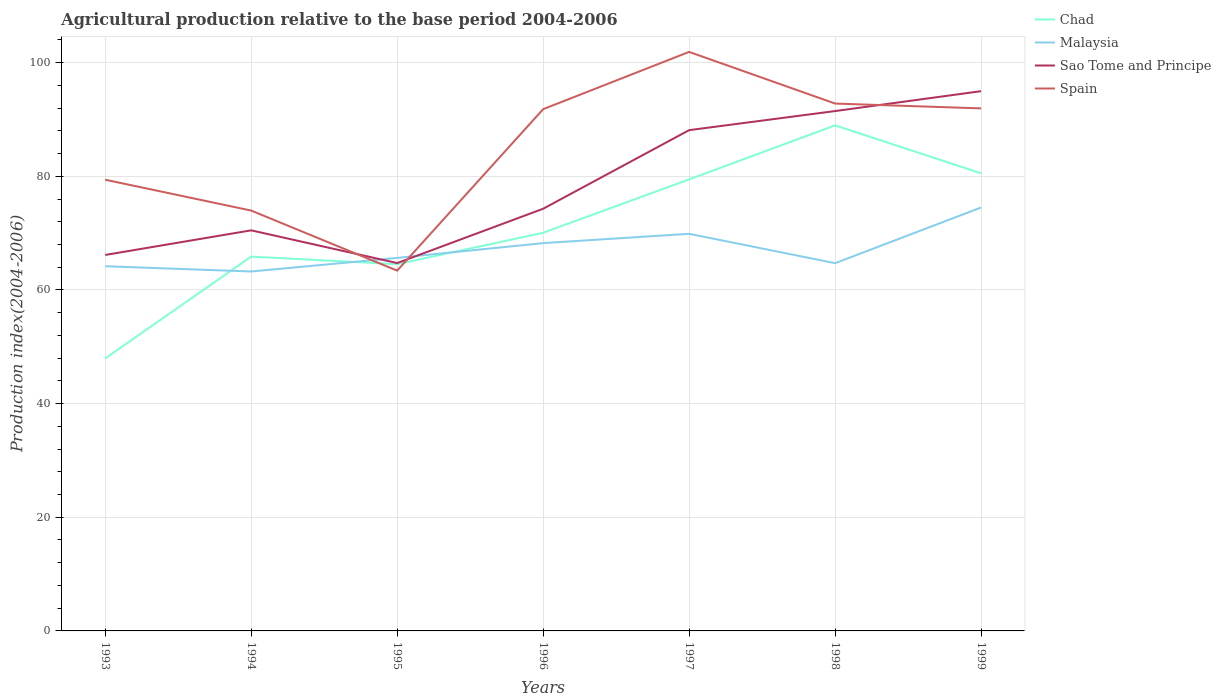Does the line corresponding to Spain intersect with the line corresponding to Malaysia?
Make the answer very short. Yes. Across all years, what is the maximum agricultural production index in Malaysia?
Keep it short and to the point. 63.25. What is the total agricultural production index in Chad in the graph?
Make the answer very short. -17.92. What is the difference between the highest and the second highest agricultural production index in Sao Tome and Principe?
Offer a very short reply. 30.25. How many lines are there?
Provide a short and direct response. 4. Where does the legend appear in the graph?
Your answer should be compact. Top right. How are the legend labels stacked?
Give a very brief answer. Vertical. What is the title of the graph?
Make the answer very short. Agricultural production relative to the base period 2004-2006. Does "Mali" appear as one of the legend labels in the graph?
Offer a very short reply. No. What is the label or title of the X-axis?
Make the answer very short. Years. What is the label or title of the Y-axis?
Provide a succinct answer. Production index(2004-2006). What is the Production index(2004-2006) in Chad in 1993?
Provide a succinct answer. 47.95. What is the Production index(2004-2006) of Malaysia in 1993?
Provide a short and direct response. 64.17. What is the Production index(2004-2006) in Sao Tome and Principe in 1993?
Give a very brief answer. 66.16. What is the Production index(2004-2006) in Spain in 1993?
Your answer should be very brief. 79.4. What is the Production index(2004-2006) of Chad in 1994?
Your response must be concise. 65.87. What is the Production index(2004-2006) in Malaysia in 1994?
Provide a succinct answer. 63.25. What is the Production index(2004-2006) in Sao Tome and Principe in 1994?
Your response must be concise. 70.49. What is the Production index(2004-2006) in Spain in 1994?
Provide a succinct answer. 73.97. What is the Production index(2004-2006) of Chad in 1995?
Provide a short and direct response. 64.53. What is the Production index(2004-2006) in Malaysia in 1995?
Make the answer very short. 65.64. What is the Production index(2004-2006) of Sao Tome and Principe in 1995?
Your answer should be very brief. 64.73. What is the Production index(2004-2006) in Spain in 1995?
Give a very brief answer. 63.4. What is the Production index(2004-2006) in Chad in 1996?
Make the answer very short. 70.06. What is the Production index(2004-2006) in Malaysia in 1996?
Provide a short and direct response. 68.24. What is the Production index(2004-2006) in Sao Tome and Principe in 1996?
Your response must be concise. 74.29. What is the Production index(2004-2006) in Spain in 1996?
Your response must be concise. 91.81. What is the Production index(2004-2006) in Chad in 1997?
Provide a succinct answer. 79.46. What is the Production index(2004-2006) in Malaysia in 1997?
Provide a short and direct response. 69.88. What is the Production index(2004-2006) in Sao Tome and Principe in 1997?
Make the answer very short. 88.12. What is the Production index(2004-2006) in Spain in 1997?
Keep it short and to the point. 101.89. What is the Production index(2004-2006) of Chad in 1998?
Your answer should be compact. 88.96. What is the Production index(2004-2006) in Malaysia in 1998?
Keep it short and to the point. 64.71. What is the Production index(2004-2006) of Sao Tome and Principe in 1998?
Your answer should be compact. 91.48. What is the Production index(2004-2006) of Spain in 1998?
Offer a very short reply. 92.8. What is the Production index(2004-2006) of Chad in 1999?
Ensure brevity in your answer.  80.53. What is the Production index(2004-2006) in Malaysia in 1999?
Give a very brief answer. 74.51. What is the Production index(2004-2006) of Sao Tome and Principe in 1999?
Make the answer very short. 94.98. What is the Production index(2004-2006) of Spain in 1999?
Your answer should be very brief. 91.95. Across all years, what is the maximum Production index(2004-2006) in Chad?
Ensure brevity in your answer.  88.96. Across all years, what is the maximum Production index(2004-2006) of Malaysia?
Your answer should be compact. 74.51. Across all years, what is the maximum Production index(2004-2006) in Sao Tome and Principe?
Make the answer very short. 94.98. Across all years, what is the maximum Production index(2004-2006) in Spain?
Your answer should be compact. 101.89. Across all years, what is the minimum Production index(2004-2006) of Chad?
Provide a short and direct response. 47.95. Across all years, what is the minimum Production index(2004-2006) of Malaysia?
Your response must be concise. 63.25. Across all years, what is the minimum Production index(2004-2006) in Sao Tome and Principe?
Offer a terse response. 64.73. Across all years, what is the minimum Production index(2004-2006) of Spain?
Your response must be concise. 63.4. What is the total Production index(2004-2006) of Chad in the graph?
Provide a succinct answer. 497.36. What is the total Production index(2004-2006) of Malaysia in the graph?
Keep it short and to the point. 470.4. What is the total Production index(2004-2006) in Sao Tome and Principe in the graph?
Keep it short and to the point. 550.25. What is the total Production index(2004-2006) of Spain in the graph?
Keep it short and to the point. 595.22. What is the difference between the Production index(2004-2006) in Chad in 1993 and that in 1994?
Provide a short and direct response. -17.92. What is the difference between the Production index(2004-2006) in Malaysia in 1993 and that in 1994?
Keep it short and to the point. 0.92. What is the difference between the Production index(2004-2006) of Sao Tome and Principe in 1993 and that in 1994?
Your response must be concise. -4.33. What is the difference between the Production index(2004-2006) in Spain in 1993 and that in 1994?
Ensure brevity in your answer.  5.43. What is the difference between the Production index(2004-2006) of Chad in 1993 and that in 1995?
Keep it short and to the point. -16.58. What is the difference between the Production index(2004-2006) of Malaysia in 1993 and that in 1995?
Keep it short and to the point. -1.47. What is the difference between the Production index(2004-2006) of Sao Tome and Principe in 1993 and that in 1995?
Your answer should be very brief. 1.43. What is the difference between the Production index(2004-2006) in Spain in 1993 and that in 1995?
Make the answer very short. 16. What is the difference between the Production index(2004-2006) in Chad in 1993 and that in 1996?
Offer a terse response. -22.11. What is the difference between the Production index(2004-2006) in Malaysia in 1993 and that in 1996?
Your answer should be compact. -4.07. What is the difference between the Production index(2004-2006) of Sao Tome and Principe in 1993 and that in 1996?
Keep it short and to the point. -8.13. What is the difference between the Production index(2004-2006) of Spain in 1993 and that in 1996?
Ensure brevity in your answer.  -12.41. What is the difference between the Production index(2004-2006) in Chad in 1993 and that in 1997?
Your answer should be very brief. -31.51. What is the difference between the Production index(2004-2006) in Malaysia in 1993 and that in 1997?
Your response must be concise. -5.71. What is the difference between the Production index(2004-2006) of Sao Tome and Principe in 1993 and that in 1997?
Ensure brevity in your answer.  -21.96. What is the difference between the Production index(2004-2006) of Spain in 1993 and that in 1997?
Provide a succinct answer. -22.49. What is the difference between the Production index(2004-2006) in Chad in 1993 and that in 1998?
Offer a very short reply. -41.01. What is the difference between the Production index(2004-2006) in Malaysia in 1993 and that in 1998?
Offer a terse response. -0.54. What is the difference between the Production index(2004-2006) of Sao Tome and Principe in 1993 and that in 1998?
Your answer should be very brief. -25.32. What is the difference between the Production index(2004-2006) of Spain in 1993 and that in 1998?
Provide a succinct answer. -13.4. What is the difference between the Production index(2004-2006) in Chad in 1993 and that in 1999?
Provide a succinct answer. -32.58. What is the difference between the Production index(2004-2006) of Malaysia in 1993 and that in 1999?
Your response must be concise. -10.34. What is the difference between the Production index(2004-2006) of Sao Tome and Principe in 1993 and that in 1999?
Provide a short and direct response. -28.82. What is the difference between the Production index(2004-2006) in Spain in 1993 and that in 1999?
Provide a short and direct response. -12.55. What is the difference between the Production index(2004-2006) of Chad in 1994 and that in 1995?
Keep it short and to the point. 1.34. What is the difference between the Production index(2004-2006) in Malaysia in 1994 and that in 1995?
Offer a very short reply. -2.39. What is the difference between the Production index(2004-2006) in Sao Tome and Principe in 1994 and that in 1995?
Provide a short and direct response. 5.76. What is the difference between the Production index(2004-2006) in Spain in 1994 and that in 1995?
Ensure brevity in your answer.  10.57. What is the difference between the Production index(2004-2006) of Chad in 1994 and that in 1996?
Give a very brief answer. -4.19. What is the difference between the Production index(2004-2006) in Malaysia in 1994 and that in 1996?
Provide a short and direct response. -4.99. What is the difference between the Production index(2004-2006) of Spain in 1994 and that in 1996?
Give a very brief answer. -17.84. What is the difference between the Production index(2004-2006) of Chad in 1994 and that in 1997?
Offer a very short reply. -13.59. What is the difference between the Production index(2004-2006) of Malaysia in 1994 and that in 1997?
Your answer should be compact. -6.63. What is the difference between the Production index(2004-2006) in Sao Tome and Principe in 1994 and that in 1997?
Your answer should be compact. -17.63. What is the difference between the Production index(2004-2006) in Spain in 1994 and that in 1997?
Provide a short and direct response. -27.92. What is the difference between the Production index(2004-2006) of Chad in 1994 and that in 1998?
Your response must be concise. -23.09. What is the difference between the Production index(2004-2006) in Malaysia in 1994 and that in 1998?
Make the answer very short. -1.46. What is the difference between the Production index(2004-2006) of Sao Tome and Principe in 1994 and that in 1998?
Give a very brief answer. -20.99. What is the difference between the Production index(2004-2006) of Spain in 1994 and that in 1998?
Your answer should be very brief. -18.83. What is the difference between the Production index(2004-2006) of Chad in 1994 and that in 1999?
Provide a short and direct response. -14.66. What is the difference between the Production index(2004-2006) of Malaysia in 1994 and that in 1999?
Your answer should be compact. -11.26. What is the difference between the Production index(2004-2006) in Sao Tome and Principe in 1994 and that in 1999?
Your response must be concise. -24.49. What is the difference between the Production index(2004-2006) of Spain in 1994 and that in 1999?
Ensure brevity in your answer.  -17.98. What is the difference between the Production index(2004-2006) in Chad in 1995 and that in 1996?
Offer a terse response. -5.53. What is the difference between the Production index(2004-2006) of Malaysia in 1995 and that in 1996?
Offer a terse response. -2.6. What is the difference between the Production index(2004-2006) of Sao Tome and Principe in 1995 and that in 1996?
Your answer should be very brief. -9.56. What is the difference between the Production index(2004-2006) in Spain in 1995 and that in 1996?
Provide a short and direct response. -28.41. What is the difference between the Production index(2004-2006) in Chad in 1995 and that in 1997?
Provide a succinct answer. -14.93. What is the difference between the Production index(2004-2006) of Malaysia in 1995 and that in 1997?
Your answer should be very brief. -4.24. What is the difference between the Production index(2004-2006) in Sao Tome and Principe in 1995 and that in 1997?
Your answer should be very brief. -23.39. What is the difference between the Production index(2004-2006) of Spain in 1995 and that in 1997?
Ensure brevity in your answer.  -38.49. What is the difference between the Production index(2004-2006) in Chad in 1995 and that in 1998?
Your answer should be very brief. -24.43. What is the difference between the Production index(2004-2006) in Sao Tome and Principe in 1995 and that in 1998?
Give a very brief answer. -26.75. What is the difference between the Production index(2004-2006) of Spain in 1995 and that in 1998?
Ensure brevity in your answer.  -29.4. What is the difference between the Production index(2004-2006) of Malaysia in 1995 and that in 1999?
Make the answer very short. -8.87. What is the difference between the Production index(2004-2006) in Sao Tome and Principe in 1995 and that in 1999?
Ensure brevity in your answer.  -30.25. What is the difference between the Production index(2004-2006) of Spain in 1995 and that in 1999?
Offer a very short reply. -28.55. What is the difference between the Production index(2004-2006) of Malaysia in 1996 and that in 1997?
Ensure brevity in your answer.  -1.64. What is the difference between the Production index(2004-2006) of Sao Tome and Principe in 1996 and that in 1997?
Your answer should be compact. -13.83. What is the difference between the Production index(2004-2006) in Spain in 1996 and that in 1997?
Offer a terse response. -10.08. What is the difference between the Production index(2004-2006) of Chad in 1996 and that in 1998?
Your answer should be very brief. -18.9. What is the difference between the Production index(2004-2006) of Malaysia in 1996 and that in 1998?
Offer a very short reply. 3.53. What is the difference between the Production index(2004-2006) in Sao Tome and Principe in 1996 and that in 1998?
Your answer should be compact. -17.19. What is the difference between the Production index(2004-2006) of Spain in 1996 and that in 1998?
Your answer should be compact. -0.99. What is the difference between the Production index(2004-2006) in Chad in 1996 and that in 1999?
Your answer should be compact. -10.47. What is the difference between the Production index(2004-2006) of Malaysia in 1996 and that in 1999?
Provide a succinct answer. -6.27. What is the difference between the Production index(2004-2006) of Sao Tome and Principe in 1996 and that in 1999?
Provide a succinct answer. -20.69. What is the difference between the Production index(2004-2006) in Spain in 1996 and that in 1999?
Ensure brevity in your answer.  -0.14. What is the difference between the Production index(2004-2006) of Chad in 1997 and that in 1998?
Offer a very short reply. -9.5. What is the difference between the Production index(2004-2006) in Malaysia in 1997 and that in 1998?
Ensure brevity in your answer.  5.17. What is the difference between the Production index(2004-2006) in Sao Tome and Principe in 1997 and that in 1998?
Offer a terse response. -3.36. What is the difference between the Production index(2004-2006) in Spain in 1997 and that in 1998?
Your answer should be compact. 9.09. What is the difference between the Production index(2004-2006) in Chad in 1997 and that in 1999?
Offer a terse response. -1.07. What is the difference between the Production index(2004-2006) of Malaysia in 1997 and that in 1999?
Provide a short and direct response. -4.63. What is the difference between the Production index(2004-2006) in Sao Tome and Principe in 1997 and that in 1999?
Provide a succinct answer. -6.86. What is the difference between the Production index(2004-2006) of Spain in 1997 and that in 1999?
Offer a terse response. 9.94. What is the difference between the Production index(2004-2006) of Chad in 1998 and that in 1999?
Provide a succinct answer. 8.43. What is the difference between the Production index(2004-2006) of Chad in 1993 and the Production index(2004-2006) of Malaysia in 1994?
Your response must be concise. -15.3. What is the difference between the Production index(2004-2006) of Chad in 1993 and the Production index(2004-2006) of Sao Tome and Principe in 1994?
Give a very brief answer. -22.54. What is the difference between the Production index(2004-2006) in Chad in 1993 and the Production index(2004-2006) in Spain in 1994?
Provide a succinct answer. -26.02. What is the difference between the Production index(2004-2006) in Malaysia in 1993 and the Production index(2004-2006) in Sao Tome and Principe in 1994?
Offer a terse response. -6.32. What is the difference between the Production index(2004-2006) of Sao Tome and Principe in 1993 and the Production index(2004-2006) of Spain in 1994?
Offer a very short reply. -7.81. What is the difference between the Production index(2004-2006) in Chad in 1993 and the Production index(2004-2006) in Malaysia in 1995?
Make the answer very short. -17.69. What is the difference between the Production index(2004-2006) of Chad in 1993 and the Production index(2004-2006) of Sao Tome and Principe in 1995?
Your response must be concise. -16.78. What is the difference between the Production index(2004-2006) of Chad in 1993 and the Production index(2004-2006) of Spain in 1995?
Make the answer very short. -15.45. What is the difference between the Production index(2004-2006) of Malaysia in 1993 and the Production index(2004-2006) of Sao Tome and Principe in 1995?
Keep it short and to the point. -0.56. What is the difference between the Production index(2004-2006) of Malaysia in 1993 and the Production index(2004-2006) of Spain in 1995?
Keep it short and to the point. 0.77. What is the difference between the Production index(2004-2006) in Sao Tome and Principe in 1993 and the Production index(2004-2006) in Spain in 1995?
Make the answer very short. 2.76. What is the difference between the Production index(2004-2006) in Chad in 1993 and the Production index(2004-2006) in Malaysia in 1996?
Provide a succinct answer. -20.29. What is the difference between the Production index(2004-2006) in Chad in 1993 and the Production index(2004-2006) in Sao Tome and Principe in 1996?
Offer a terse response. -26.34. What is the difference between the Production index(2004-2006) in Chad in 1993 and the Production index(2004-2006) in Spain in 1996?
Make the answer very short. -43.86. What is the difference between the Production index(2004-2006) of Malaysia in 1993 and the Production index(2004-2006) of Sao Tome and Principe in 1996?
Keep it short and to the point. -10.12. What is the difference between the Production index(2004-2006) of Malaysia in 1993 and the Production index(2004-2006) of Spain in 1996?
Ensure brevity in your answer.  -27.64. What is the difference between the Production index(2004-2006) of Sao Tome and Principe in 1993 and the Production index(2004-2006) of Spain in 1996?
Keep it short and to the point. -25.65. What is the difference between the Production index(2004-2006) in Chad in 1993 and the Production index(2004-2006) in Malaysia in 1997?
Make the answer very short. -21.93. What is the difference between the Production index(2004-2006) in Chad in 1993 and the Production index(2004-2006) in Sao Tome and Principe in 1997?
Offer a very short reply. -40.17. What is the difference between the Production index(2004-2006) in Chad in 1993 and the Production index(2004-2006) in Spain in 1997?
Give a very brief answer. -53.94. What is the difference between the Production index(2004-2006) of Malaysia in 1993 and the Production index(2004-2006) of Sao Tome and Principe in 1997?
Your answer should be compact. -23.95. What is the difference between the Production index(2004-2006) of Malaysia in 1993 and the Production index(2004-2006) of Spain in 1997?
Your response must be concise. -37.72. What is the difference between the Production index(2004-2006) of Sao Tome and Principe in 1993 and the Production index(2004-2006) of Spain in 1997?
Give a very brief answer. -35.73. What is the difference between the Production index(2004-2006) of Chad in 1993 and the Production index(2004-2006) of Malaysia in 1998?
Your answer should be compact. -16.76. What is the difference between the Production index(2004-2006) in Chad in 1993 and the Production index(2004-2006) in Sao Tome and Principe in 1998?
Ensure brevity in your answer.  -43.53. What is the difference between the Production index(2004-2006) in Chad in 1993 and the Production index(2004-2006) in Spain in 1998?
Keep it short and to the point. -44.85. What is the difference between the Production index(2004-2006) of Malaysia in 1993 and the Production index(2004-2006) of Sao Tome and Principe in 1998?
Your answer should be compact. -27.31. What is the difference between the Production index(2004-2006) in Malaysia in 1993 and the Production index(2004-2006) in Spain in 1998?
Offer a terse response. -28.63. What is the difference between the Production index(2004-2006) in Sao Tome and Principe in 1993 and the Production index(2004-2006) in Spain in 1998?
Offer a very short reply. -26.64. What is the difference between the Production index(2004-2006) of Chad in 1993 and the Production index(2004-2006) of Malaysia in 1999?
Your answer should be very brief. -26.56. What is the difference between the Production index(2004-2006) in Chad in 1993 and the Production index(2004-2006) in Sao Tome and Principe in 1999?
Make the answer very short. -47.03. What is the difference between the Production index(2004-2006) of Chad in 1993 and the Production index(2004-2006) of Spain in 1999?
Your answer should be very brief. -44. What is the difference between the Production index(2004-2006) in Malaysia in 1993 and the Production index(2004-2006) in Sao Tome and Principe in 1999?
Your answer should be very brief. -30.81. What is the difference between the Production index(2004-2006) in Malaysia in 1993 and the Production index(2004-2006) in Spain in 1999?
Keep it short and to the point. -27.78. What is the difference between the Production index(2004-2006) of Sao Tome and Principe in 1993 and the Production index(2004-2006) of Spain in 1999?
Provide a succinct answer. -25.79. What is the difference between the Production index(2004-2006) in Chad in 1994 and the Production index(2004-2006) in Malaysia in 1995?
Keep it short and to the point. 0.23. What is the difference between the Production index(2004-2006) of Chad in 1994 and the Production index(2004-2006) of Sao Tome and Principe in 1995?
Provide a short and direct response. 1.14. What is the difference between the Production index(2004-2006) of Chad in 1994 and the Production index(2004-2006) of Spain in 1995?
Your answer should be very brief. 2.47. What is the difference between the Production index(2004-2006) in Malaysia in 1994 and the Production index(2004-2006) in Sao Tome and Principe in 1995?
Your answer should be compact. -1.48. What is the difference between the Production index(2004-2006) in Sao Tome and Principe in 1994 and the Production index(2004-2006) in Spain in 1995?
Keep it short and to the point. 7.09. What is the difference between the Production index(2004-2006) in Chad in 1994 and the Production index(2004-2006) in Malaysia in 1996?
Provide a short and direct response. -2.37. What is the difference between the Production index(2004-2006) of Chad in 1994 and the Production index(2004-2006) of Sao Tome and Principe in 1996?
Your answer should be compact. -8.42. What is the difference between the Production index(2004-2006) in Chad in 1994 and the Production index(2004-2006) in Spain in 1996?
Your answer should be very brief. -25.94. What is the difference between the Production index(2004-2006) in Malaysia in 1994 and the Production index(2004-2006) in Sao Tome and Principe in 1996?
Ensure brevity in your answer.  -11.04. What is the difference between the Production index(2004-2006) of Malaysia in 1994 and the Production index(2004-2006) of Spain in 1996?
Offer a terse response. -28.56. What is the difference between the Production index(2004-2006) of Sao Tome and Principe in 1994 and the Production index(2004-2006) of Spain in 1996?
Give a very brief answer. -21.32. What is the difference between the Production index(2004-2006) of Chad in 1994 and the Production index(2004-2006) of Malaysia in 1997?
Provide a succinct answer. -4.01. What is the difference between the Production index(2004-2006) of Chad in 1994 and the Production index(2004-2006) of Sao Tome and Principe in 1997?
Offer a very short reply. -22.25. What is the difference between the Production index(2004-2006) in Chad in 1994 and the Production index(2004-2006) in Spain in 1997?
Provide a succinct answer. -36.02. What is the difference between the Production index(2004-2006) in Malaysia in 1994 and the Production index(2004-2006) in Sao Tome and Principe in 1997?
Provide a short and direct response. -24.87. What is the difference between the Production index(2004-2006) of Malaysia in 1994 and the Production index(2004-2006) of Spain in 1997?
Make the answer very short. -38.64. What is the difference between the Production index(2004-2006) in Sao Tome and Principe in 1994 and the Production index(2004-2006) in Spain in 1997?
Provide a short and direct response. -31.4. What is the difference between the Production index(2004-2006) in Chad in 1994 and the Production index(2004-2006) in Malaysia in 1998?
Offer a very short reply. 1.16. What is the difference between the Production index(2004-2006) in Chad in 1994 and the Production index(2004-2006) in Sao Tome and Principe in 1998?
Provide a short and direct response. -25.61. What is the difference between the Production index(2004-2006) in Chad in 1994 and the Production index(2004-2006) in Spain in 1998?
Your answer should be very brief. -26.93. What is the difference between the Production index(2004-2006) in Malaysia in 1994 and the Production index(2004-2006) in Sao Tome and Principe in 1998?
Keep it short and to the point. -28.23. What is the difference between the Production index(2004-2006) in Malaysia in 1994 and the Production index(2004-2006) in Spain in 1998?
Provide a succinct answer. -29.55. What is the difference between the Production index(2004-2006) of Sao Tome and Principe in 1994 and the Production index(2004-2006) of Spain in 1998?
Ensure brevity in your answer.  -22.31. What is the difference between the Production index(2004-2006) in Chad in 1994 and the Production index(2004-2006) in Malaysia in 1999?
Provide a short and direct response. -8.64. What is the difference between the Production index(2004-2006) of Chad in 1994 and the Production index(2004-2006) of Sao Tome and Principe in 1999?
Your answer should be very brief. -29.11. What is the difference between the Production index(2004-2006) of Chad in 1994 and the Production index(2004-2006) of Spain in 1999?
Provide a short and direct response. -26.08. What is the difference between the Production index(2004-2006) in Malaysia in 1994 and the Production index(2004-2006) in Sao Tome and Principe in 1999?
Offer a terse response. -31.73. What is the difference between the Production index(2004-2006) in Malaysia in 1994 and the Production index(2004-2006) in Spain in 1999?
Keep it short and to the point. -28.7. What is the difference between the Production index(2004-2006) in Sao Tome and Principe in 1994 and the Production index(2004-2006) in Spain in 1999?
Provide a short and direct response. -21.46. What is the difference between the Production index(2004-2006) of Chad in 1995 and the Production index(2004-2006) of Malaysia in 1996?
Offer a very short reply. -3.71. What is the difference between the Production index(2004-2006) of Chad in 1995 and the Production index(2004-2006) of Sao Tome and Principe in 1996?
Your answer should be very brief. -9.76. What is the difference between the Production index(2004-2006) of Chad in 1995 and the Production index(2004-2006) of Spain in 1996?
Ensure brevity in your answer.  -27.28. What is the difference between the Production index(2004-2006) of Malaysia in 1995 and the Production index(2004-2006) of Sao Tome and Principe in 1996?
Provide a succinct answer. -8.65. What is the difference between the Production index(2004-2006) of Malaysia in 1995 and the Production index(2004-2006) of Spain in 1996?
Keep it short and to the point. -26.17. What is the difference between the Production index(2004-2006) in Sao Tome and Principe in 1995 and the Production index(2004-2006) in Spain in 1996?
Provide a succinct answer. -27.08. What is the difference between the Production index(2004-2006) in Chad in 1995 and the Production index(2004-2006) in Malaysia in 1997?
Make the answer very short. -5.35. What is the difference between the Production index(2004-2006) of Chad in 1995 and the Production index(2004-2006) of Sao Tome and Principe in 1997?
Provide a short and direct response. -23.59. What is the difference between the Production index(2004-2006) of Chad in 1995 and the Production index(2004-2006) of Spain in 1997?
Give a very brief answer. -37.36. What is the difference between the Production index(2004-2006) in Malaysia in 1995 and the Production index(2004-2006) in Sao Tome and Principe in 1997?
Keep it short and to the point. -22.48. What is the difference between the Production index(2004-2006) in Malaysia in 1995 and the Production index(2004-2006) in Spain in 1997?
Offer a very short reply. -36.25. What is the difference between the Production index(2004-2006) of Sao Tome and Principe in 1995 and the Production index(2004-2006) of Spain in 1997?
Offer a terse response. -37.16. What is the difference between the Production index(2004-2006) of Chad in 1995 and the Production index(2004-2006) of Malaysia in 1998?
Offer a very short reply. -0.18. What is the difference between the Production index(2004-2006) in Chad in 1995 and the Production index(2004-2006) in Sao Tome and Principe in 1998?
Give a very brief answer. -26.95. What is the difference between the Production index(2004-2006) in Chad in 1995 and the Production index(2004-2006) in Spain in 1998?
Your answer should be compact. -28.27. What is the difference between the Production index(2004-2006) of Malaysia in 1995 and the Production index(2004-2006) of Sao Tome and Principe in 1998?
Keep it short and to the point. -25.84. What is the difference between the Production index(2004-2006) of Malaysia in 1995 and the Production index(2004-2006) of Spain in 1998?
Give a very brief answer. -27.16. What is the difference between the Production index(2004-2006) in Sao Tome and Principe in 1995 and the Production index(2004-2006) in Spain in 1998?
Your response must be concise. -28.07. What is the difference between the Production index(2004-2006) in Chad in 1995 and the Production index(2004-2006) in Malaysia in 1999?
Ensure brevity in your answer.  -9.98. What is the difference between the Production index(2004-2006) in Chad in 1995 and the Production index(2004-2006) in Sao Tome and Principe in 1999?
Give a very brief answer. -30.45. What is the difference between the Production index(2004-2006) of Chad in 1995 and the Production index(2004-2006) of Spain in 1999?
Ensure brevity in your answer.  -27.42. What is the difference between the Production index(2004-2006) in Malaysia in 1995 and the Production index(2004-2006) in Sao Tome and Principe in 1999?
Your response must be concise. -29.34. What is the difference between the Production index(2004-2006) in Malaysia in 1995 and the Production index(2004-2006) in Spain in 1999?
Make the answer very short. -26.31. What is the difference between the Production index(2004-2006) of Sao Tome and Principe in 1995 and the Production index(2004-2006) of Spain in 1999?
Keep it short and to the point. -27.22. What is the difference between the Production index(2004-2006) in Chad in 1996 and the Production index(2004-2006) in Malaysia in 1997?
Give a very brief answer. 0.18. What is the difference between the Production index(2004-2006) of Chad in 1996 and the Production index(2004-2006) of Sao Tome and Principe in 1997?
Provide a short and direct response. -18.06. What is the difference between the Production index(2004-2006) in Chad in 1996 and the Production index(2004-2006) in Spain in 1997?
Provide a succinct answer. -31.83. What is the difference between the Production index(2004-2006) in Malaysia in 1996 and the Production index(2004-2006) in Sao Tome and Principe in 1997?
Offer a very short reply. -19.88. What is the difference between the Production index(2004-2006) in Malaysia in 1996 and the Production index(2004-2006) in Spain in 1997?
Ensure brevity in your answer.  -33.65. What is the difference between the Production index(2004-2006) in Sao Tome and Principe in 1996 and the Production index(2004-2006) in Spain in 1997?
Provide a short and direct response. -27.6. What is the difference between the Production index(2004-2006) of Chad in 1996 and the Production index(2004-2006) of Malaysia in 1998?
Offer a terse response. 5.35. What is the difference between the Production index(2004-2006) in Chad in 1996 and the Production index(2004-2006) in Sao Tome and Principe in 1998?
Make the answer very short. -21.42. What is the difference between the Production index(2004-2006) in Chad in 1996 and the Production index(2004-2006) in Spain in 1998?
Offer a very short reply. -22.74. What is the difference between the Production index(2004-2006) in Malaysia in 1996 and the Production index(2004-2006) in Sao Tome and Principe in 1998?
Ensure brevity in your answer.  -23.24. What is the difference between the Production index(2004-2006) of Malaysia in 1996 and the Production index(2004-2006) of Spain in 1998?
Offer a very short reply. -24.56. What is the difference between the Production index(2004-2006) in Sao Tome and Principe in 1996 and the Production index(2004-2006) in Spain in 1998?
Provide a succinct answer. -18.51. What is the difference between the Production index(2004-2006) of Chad in 1996 and the Production index(2004-2006) of Malaysia in 1999?
Give a very brief answer. -4.45. What is the difference between the Production index(2004-2006) in Chad in 1996 and the Production index(2004-2006) in Sao Tome and Principe in 1999?
Give a very brief answer. -24.92. What is the difference between the Production index(2004-2006) of Chad in 1996 and the Production index(2004-2006) of Spain in 1999?
Ensure brevity in your answer.  -21.89. What is the difference between the Production index(2004-2006) in Malaysia in 1996 and the Production index(2004-2006) in Sao Tome and Principe in 1999?
Ensure brevity in your answer.  -26.74. What is the difference between the Production index(2004-2006) in Malaysia in 1996 and the Production index(2004-2006) in Spain in 1999?
Your response must be concise. -23.71. What is the difference between the Production index(2004-2006) in Sao Tome and Principe in 1996 and the Production index(2004-2006) in Spain in 1999?
Ensure brevity in your answer.  -17.66. What is the difference between the Production index(2004-2006) of Chad in 1997 and the Production index(2004-2006) of Malaysia in 1998?
Make the answer very short. 14.75. What is the difference between the Production index(2004-2006) in Chad in 1997 and the Production index(2004-2006) in Sao Tome and Principe in 1998?
Your answer should be very brief. -12.02. What is the difference between the Production index(2004-2006) in Chad in 1997 and the Production index(2004-2006) in Spain in 1998?
Your response must be concise. -13.34. What is the difference between the Production index(2004-2006) of Malaysia in 1997 and the Production index(2004-2006) of Sao Tome and Principe in 1998?
Offer a very short reply. -21.6. What is the difference between the Production index(2004-2006) of Malaysia in 1997 and the Production index(2004-2006) of Spain in 1998?
Keep it short and to the point. -22.92. What is the difference between the Production index(2004-2006) of Sao Tome and Principe in 1997 and the Production index(2004-2006) of Spain in 1998?
Your answer should be compact. -4.68. What is the difference between the Production index(2004-2006) in Chad in 1997 and the Production index(2004-2006) in Malaysia in 1999?
Offer a very short reply. 4.95. What is the difference between the Production index(2004-2006) in Chad in 1997 and the Production index(2004-2006) in Sao Tome and Principe in 1999?
Your answer should be very brief. -15.52. What is the difference between the Production index(2004-2006) in Chad in 1997 and the Production index(2004-2006) in Spain in 1999?
Make the answer very short. -12.49. What is the difference between the Production index(2004-2006) in Malaysia in 1997 and the Production index(2004-2006) in Sao Tome and Principe in 1999?
Provide a succinct answer. -25.1. What is the difference between the Production index(2004-2006) in Malaysia in 1997 and the Production index(2004-2006) in Spain in 1999?
Offer a terse response. -22.07. What is the difference between the Production index(2004-2006) of Sao Tome and Principe in 1997 and the Production index(2004-2006) of Spain in 1999?
Provide a short and direct response. -3.83. What is the difference between the Production index(2004-2006) in Chad in 1998 and the Production index(2004-2006) in Malaysia in 1999?
Offer a terse response. 14.45. What is the difference between the Production index(2004-2006) of Chad in 1998 and the Production index(2004-2006) of Sao Tome and Principe in 1999?
Ensure brevity in your answer.  -6.02. What is the difference between the Production index(2004-2006) in Chad in 1998 and the Production index(2004-2006) in Spain in 1999?
Your response must be concise. -2.99. What is the difference between the Production index(2004-2006) in Malaysia in 1998 and the Production index(2004-2006) in Sao Tome and Principe in 1999?
Give a very brief answer. -30.27. What is the difference between the Production index(2004-2006) in Malaysia in 1998 and the Production index(2004-2006) in Spain in 1999?
Make the answer very short. -27.24. What is the difference between the Production index(2004-2006) in Sao Tome and Principe in 1998 and the Production index(2004-2006) in Spain in 1999?
Offer a very short reply. -0.47. What is the average Production index(2004-2006) of Chad per year?
Keep it short and to the point. 71.05. What is the average Production index(2004-2006) of Malaysia per year?
Your answer should be very brief. 67.2. What is the average Production index(2004-2006) of Sao Tome and Principe per year?
Offer a terse response. 78.61. What is the average Production index(2004-2006) in Spain per year?
Offer a very short reply. 85.03. In the year 1993, what is the difference between the Production index(2004-2006) in Chad and Production index(2004-2006) in Malaysia?
Offer a very short reply. -16.22. In the year 1993, what is the difference between the Production index(2004-2006) of Chad and Production index(2004-2006) of Sao Tome and Principe?
Keep it short and to the point. -18.21. In the year 1993, what is the difference between the Production index(2004-2006) of Chad and Production index(2004-2006) of Spain?
Your answer should be very brief. -31.45. In the year 1993, what is the difference between the Production index(2004-2006) of Malaysia and Production index(2004-2006) of Sao Tome and Principe?
Offer a very short reply. -1.99. In the year 1993, what is the difference between the Production index(2004-2006) of Malaysia and Production index(2004-2006) of Spain?
Offer a very short reply. -15.23. In the year 1993, what is the difference between the Production index(2004-2006) in Sao Tome and Principe and Production index(2004-2006) in Spain?
Provide a succinct answer. -13.24. In the year 1994, what is the difference between the Production index(2004-2006) of Chad and Production index(2004-2006) of Malaysia?
Keep it short and to the point. 2.62. In the year 1994, what is the difference between the Production index(2004-2006) of Chad and Production index(2004-2006) of Sao Tome and Principe?
Your answer should be compact. -4.62. In the year 1994, what is the difference between the Production index(2004-2006) in Malaysia and Production index(2004-2006) in Sao Tome and Principe?
Keep it short and to the point. -7.24. In the year 1994, what is the difference between the Production index(2004-2006) in Malaysia and Production index(2004-2006) in Spain?
Provide a short and direct response. -10.72. In the year 1994, what is the difference between the Production index(2004-2006) in Sao Tome and Principe and Production index(2004-2006) in Spain?
Give a very brief answer. -3.48. In the year 1995, what is the difference between the Production index(2004-2006) in Chad and Production index(2004-2006) in Malaysia?
Keep it short and to the point. -1.11. In the year 1995, what is the difference between the Production index(2004-2006) of Chad and Production index(2004-2006) of Sao Tome and Principe?
Your answer should be compact. -0.2. In the year 1995, what is the difference between the Production index(2004-2006) in Chad and Production index(2004-2006) in Spain?
Your response must be concise. 1.13. In the year 1995, what is the difference between the Production index(2004-2006) in Malaysia and Production index(2004-2006) in Sao Tome and Principe?
Your answer should be very brief. 0.91. In the year 1995, what is the difference between the Production index(2004-2006) of Malaysia and Production index(2004-2006) of Spain?
Offer a terse response. 2.24. In the year 1995, what is the difference between the Production index(2004-2006) in Sao Tome and Principe and Production index(2004-2006) in Spain?
Make the answer very short. 1.33. In the year 1996, what is the difference between the Production index(2004-2006) in Chad and Production index(2004-2006) in Malaysia?
Your answer should be very brief. 1.82. In the year 1996, what is the difference between the Production index(2004-2006) of Chad and Production index(2004-2006) of Sao Tome and Principe?
Offer a terse response. -4.23. In the year 1996, what is the difference between the Production index(2004-2006) in Chad and Production index(2004-2006) in Spain?
Make the answer very short. -21.75. In the year 1996, what is the difference between the Production index(2004-2006) of Malaysia and Production index(2004-2006) of Sao Tome and Principe?
Keep it short and to the point. -6.05. In the year 1996, what is the difference between the Production index(2004-2006) in Malaysia and Production index(2004-2006) in Spain?
Provide a succinct answer. -23.57. In the year 1996, what is the difference between the Production index(2004-2006) in Sao Tome and Principe and Production index(2004-2006) in Spain?
Ensure brevity in your answer.  -17.52. In the year 1997, what is the difference between the Production index(2004-2006) of Chad and Production index(2004-2006) of Malaysia?
Your answer should be compact. 9.58. In the year 1997, what is the difference between the Production index(2004-2006) in Chad and Production index(2004-2006) in Sao Tome and Principe?
Ensure brevity in your answer.  -8.66. In the year 1997, what is the difference between the Production index(2004-2006) in Chad and Production index(2004-2006) in Spain?
Make the answer very short. -22.43. In the year 1997, what is the difference between the Production index(2004-2006) in Malaysia and Production index(2004-2006) in Sao Tome and Principe?
Provide a short and direct response. -18.24. In the year 1997, what is the difference between the Production index(2004-2006) of Malaysia and Production index(2004-2006) of Spain?
Give a very brief answer. -32.01. In the year 1997, what is the difference between the Production index(2004-2006) in Sao Tome and Principe and Production index(2004-2006) in Spain?
Keep it short and to the point. -13.77. In the year 1998, what is the difference between the Production index(2004-2006) in Chad and Production index(2004-2006) in Malaysia?
Ensure brevity in your answer.  24.25. In the year 1998, what is the difference between the Production index(2004-2006) in Chad and Production index(2004-2006) in Sao Tome and Principe?
Your answer should be very brief. -2.52. In the year 1998, what is the difference between the Production index(2004-2006) in Chad and Production index(2004-2006) in Spain?
Your answer should be very brief. -3.84. In the year 1998, what is the difference between the Production index(2004-2006) of Malaysia and Production index(2004-2006) of Sao Tome and Principe?
Ensure brevity in your answer.  -26.77. In the year 1998, what is the difference between the Production index(2004-2006) of Malaysia and Production index(2004-2006) of Spain?
Keep it short and to the point. -28.09. In the year 1998, what is the difference between the Production index(2004-2006) in Sao Tome and Principe and Production index(2004-2006) in Spain?
Your answer should be compact. -1.32. In the year 1999, what is the difference between the Production index(2004-2006) of Chad and Production index(2004-2006) of Malaysia?
Provide a succinct answer. 6.02. In the year 1999, what is the difference between the Production index(2004-2006) of Chad and Production index(2004-2006) of Sao Tome and Principe?
Offer a very short reply. -14.45. In the year 1999, what is the difference between the Production index(2004-2006) of Chad and Production index(2004-2006) of Spain?
Make the answer very short. -11.42. In the year 1999, what is the difference between the Production index(2004-2006) of Malaysia and Production index(2004-2006) of Sao Tome and Principe?
Your response must be concise. -20.47. In the year 1999, what is the difference between the Production index(2004-2006) in Malaysia and Production index(2004-2006) in Spain?
Keep it short and to the point. -17.44. In the year 1999, what is the difference between the Production index(2004-2006) of Sao Tome and Principe and Production index(2004-2006) of Spain?
Give a very brief answer. 3.03. What is the ratio of the Production index(2004-2006) of Chad in 1993 to that in 1994?
Offer a very short reply. 0.73. What is the ratio of the Production index(2004-2006) of Malaysia in 1993 to that in 1994?
Your answer should be compact. 1.01. What is the ratio of the Production index(2004-2006) of Sao Tome and Principe in 1993 to that in 1994?
Ensure brevity in your answer.  0.94. What is the ratio of the Production index(2004-2006) of Spain in 1993 to that in 1994?
Your response must be concise. 1.07. What is the ratio of the Production index(2004-2006) of Chad in 1993 to that in 1995?
Your answer should be very brief. 0.74. What is the ratio of the Production index(2004-2006) in Malaysia in 1993 to that in 1995?
Offer a terse response. 0.98. What is the ratio of the Production index(2004-2006) of Sao Tome and Principe in 1993 to that in 1995?
Offer a very short reply. 1.02. What is the ratio of the Production index(2004-2006) in Spain in 1993 to that in 1995?
Offer a very short reply. 1.25. What is the ratio of the Production index(2004-2006) of Chad in 1993 to that in 1996?
Your response must be concise. 0.68. What is the ratio of the Production index(2004-2006) of Malaysia in 1993 to that in 1996?
Provide a short and direct response. 0.94. What is the ratio of the Production index(2004-2006) in Sao Tome and Principe in 1993 to that in 1996?
Make the answer very short. 0.89. What is the ratio of the Production index(2004-2006) in Spain in 1993 to that in 1996?
Keep it short and to the point. 0.86. What is the ratio of the Production index(2004-2006) of Chad in 1993 to that in 1997?
Offer a terse response. 0.6. What is the ratio of the Production index(2004-2006) of Malaysia in 1993 to that in 1997?
Keep it short and to the point. 0.92. What is the ratio of the Production index(2004-2006) in Sao Tome and Principe in 1993 to that in 1997?
Keep it short and to the point. 0.75. What is the ratio of the Production index(2004-2006) of Spain in 1993 to that in 1997?
Keep it short and to the point. 0.78. What is the ratio of the Production index(2004-2006) of Chad in 1993 to that in 1998?
Give a very brief answer. 0.54. What is the ratio of the Production index(2004-2006) in Malaysia in 1993 to that in 1998?
Offer a terse response. 0.99. What is the ratio of the Production index(2004-2006) of Sao Tome and Principe in 1993 to that in 1998?
Offer a very short reply. 0.72. What is the ratio of the Production index(2004-2006) of Spain in 1993 to that in 1998?
Offer a terse response. 0.86. What is the ratio of the Production index(2004-2006) of Chad in 1993 to that in 1999?
Provide a succinct answer. 0.6. What is the ratio of the Production index(2004-2006) of Malaysia in 1993 to that in 1999?
Your answer should be compact. 0.86. What is the ratio of the Production index(2004-2006) of Sao Tome and Principe in 1993 to that in 1999?
Ensure brevity in your answer.  0.7. What is the ratio of the Production index(2004-2006) in Spain in 1993 to that in 1999?
Make the answer very short. 0.86. What is the ratio of the Production index(2004-2006) in Chad in 1994 to that in 1995?
Offer a very short reply. 1.02. What is the ratio of the Production index(2004-2006) in Malaysia in 1994 to that in 1995?
Give a very brief answer. 0.96. What is the ratio of the Production index(2004-2006) in Sao Tome and Principe in 1994 to that in 1995?
Provide a short and direct response. 1.09. What is the ratio of the Production index(2004-2006) of Chad in 1994 to that in 1996?
Keep it short and to the point. 0.94. What is the ratio of the Production index(2004-2006) of Malaysia in 1994 to that in 1996?
Offer a very short reply. 0.93. What is the ratio of the Production index(2004-2006) in Sao Tome and Principe in 1994 to that in 1996?
Offer a very short reply. 0.95. What is the ratio of the Production index(2004-2006) in Spain in 1994 to that in 1996?
Your response must be concise. 0.81. What is the ratio of the Production index(2004-2006) in Chad in 1994 to that in 1997?
Provide a succinct answer. 0.83. What is the ratio of the Production index(2004-2006) in Malaysia in 1994 to that in 1997?
Keep it short and to the point. 0.91. What is the ratio of the Production index(2004-2006) in Sao Tome and Principe in 1994 to that in 1997?
Give a very brief answer. 0.8. What is the ratio of the Production index(2004-2006) in Spain in 1994 to that in 1997?
Ensure brevity in your answer.  0.73. What is the ratio of the Production index(2004-2006) of Chad in 1994 to that in 1998?
Offer a very short reply. 0.74. What is the ratio of the Production index(2004-2006) of Malaysia in 1994 to that in 1998?
Give a very brief answer. 0.98. What is the ratio of the Production index(2004-2006) of Sao Tome and Principe in 1994 to that in 1998?
Your answer should be compact. 0.77. What is the ratio of the Production index(2004-2006) in Spain in 1994 to that in 1998?
Your response must be concise. 0.8. What is the ratio of the Production index(2004-2006) of Chad in 1994 to that in 1999?
Your answer should be very brief. 0.82. What is the ratio of the Production index(2004-2006) in Malaysia in 1994 to that in 1999?
Make the answer very short. 0.85. What is the ratio of the Production index(2004-2006) of Sao Tome and Principe in 1994 to that in 1999?
Offer a terse response. 0.74. What is the ratio of the Production index(2004-2006) of Spain in 1994 to that in 1999?
Offer a very short reply. 0.8. What is the ratio of the Production index(2004-2006) in Chad in 1995 to that in 1996?
Your answer should be very brief. 0.92. What is the ratio of the Production index(2004-2006) of Malaysia in 1995 to that in 1996?
Offer a very short reply. 0.96. What is the ratio of the Production index(2004-2006) of Sao Tome and Principe in 1995 to that in 1996?
Your answer should be compact. 0.87. What is the ratio of the Production index(2004-2006) of Spain in 1995 to that in 1996?
Make the answer very short. 0.69. What is the ratio of the Production index(2004-2006) of Chad in 1995 to that in 1997?
Provide a succinct answer. 0.81. What is the ratio of the Production index(2004-2006) of Malaysia in 1995 to that in 1997?
Your answer should be very brief. 0.94. What is the ratio of the Production index(2004-2006) of Sao Tome and Principe in 1995 to that in 1997?
Offer a terse response. 0.73. What is the ratio of the Production index(2004-2006) of Spain in 1995 to that in 1997?
Offer a terse response. 0.62. What is the ratio of the Production index(2004-2006) in Chad in 1995 to that in 1998?
Offer a very short reply. 0.73. What is the ratio of the Production index(2004-2006) of Malaysia in 1995 to that in 1998?
Make the answer very short. 1.01. What is the ratio of the Production index(2004-2006) of Sao Tome and Principe in 1995 to that in 1998?
Offer a very short reply. 0.71. What is the ratio of the Production index(2004-2006) of Spain in 1995 to that in 1998?
Your answer should be compact. 0.68. What is the ratio of the Production index(2004-2006) in Chad in 1995 to that in 1999?
Provide a succinct answer. 0.8. What is the ratio of the Production index(2004-2006) in Malaysia in 1995 to that in 1999?
Your answer should be compact. 0.88. What is the ratio of the Production index(2004-2006) in Sao Tome and Principe in 1995 to that in 1999?
Your answer should be very brief. 0.68. What is the ratio of the Production index(2004-2006) in Spain in 1995 to that in 1999?
Your answer should be very brief. 0.69. What is the ratio of the Production index(2004-2006) in Chad in 1996 to that in 1997?
Offer a terse response. 0.88. What is the ratio of the Production index(2004-2006) in Malaysia in 1996 to that in 1997?
Your answer should be compact. 0.98. What is the ratio of the Production index(2004-2006) of Sao Tome and Principe in 1996 to that in 1997?
Keep it short and to the point. 0.84. What is the ratio of the Production index(2004-2006) in Spain in 1996 to that in 1997?
Give a very brief answer. 0.9. What is the ratio of the Production index(2004-2006) in Chad in 1996 to that in 1998?
Make the answer very short. 0.79. What is the ratio of the Production index(2004-2006) in Malaysia in 1996 to that in 1998?
Give a very brief answer. 1.05. What is the ratio of the Production index(2004-2006) in Sao Tome and Principe in 1996 to that in 1998?
Your response must be concise. 0.81. What is the ratio of the Production index(2004-2006) of Spain in 1996 to that in 1998?
Make the answer very short. 0.99. What is the ratio of the Production index(2004-2006) in Chad in 1996 to that in 1999?
Make the answer very short. 0.87. What is the ratio of the Production index(2004-2006) of Malaysia in 1996 to that in 1999?
Your response must be concise. 0.92. What is the ratio of the Production index(2004-2006) in Sao Tome and Principe in 1996 to that in 1999?
Offer a terse response. 0.78. What is the ratio of the Production index(2004-2006) in Chad in 1997 to that in 1998?
Your answer should be very brief. 0.89. What is the ratio of the Production index(2004-2006) of Malaysia in 1997 to that in 1998?
Your answer should be compact. 1.08. What is the ratio of the Production index(2004-2006) in Sao Tome and Principe in 1997 to that in 1998?
Your answer should be compact. 0.96. What is the ratio of the Production index(2004-2006) of Spain in 1997 to that in 1998?
Your answer should be compact. 1.1. What is the ratio of the Production index(2004-2006) in Chad in 1997 to that in 1999?
Provide a succinct answer. 0.99. What is the ratio of the Production index(2004-2006) in Malaysia in 1997 to that in 1999?
Your answer should be compact. 0.94. What is the ratio of the Production index(2004-2006) of Sao Tome and Principe in 1997 to that in 1999?
Offer a terse response. 0.93. What is the ratio of the Production index(2004-2006) of Spain in 1997 to that in 1999?
Provide a succinct answer. 1.11. What is the ratio of the Production index(2004-2006) in Chad in 1998 to that in 1999?
Provide a short and direct response. 1.1. What is the ratio of the Production index(2004-2006) in Malaysia in 1998 to that in 1999?
Your answer should be compact. 0.87. What is the ratio of the Production index(2004-2006) of Sao Tome and Principe in 1998 to that in 1999?
Provide a short and direct response. 0.96. What is the ratio of the Production index(2004-2006) in Spain in 1998 to that in 1999?
Provide a succinct answer. 1.01. What is the difference between the highest and the second highest Production index(2004-2006) of Chad?
Provide a succinct answer. 8.43. What is the difference between the highest and the second highest Production index(2004-2006) of Malaysia?
Ensure brevity in your answer.  4.63. What is the difference between the highest and the second highest Production index(2004-2006) in Sao Tome and Principe?
Your response must be concise. 3.5. What is the difference between the highest and the second highest Production index(2004-2006) of Spain?
Your answer should be very brief. 9.09. What is the difference between the highest and the lowest Production index(2004-2006) in Chad?
Offer a very short reply. 41.01. What is the difference between the highest and the lowest Production index(2004-2006) in Malaysia?
Offer a very short reply. 11.26. What is the difference between the highest and the lowest Production index(2004-2006) in Sao Tome and Principe?
Your response must be concise. 30.25. What is the difference between the highest and the lowest Production index(2004-2006) in Spain?
Your answer should be compact. 38.49. 